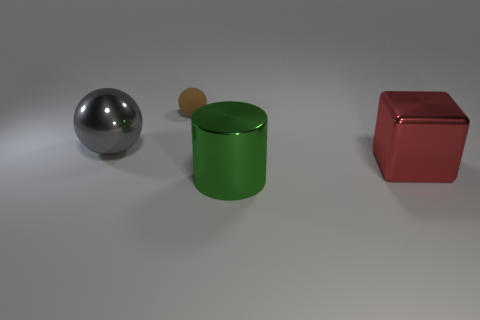Is there any other thing that has the same material as the small sphere?
Your answer should be very brief. No. How many objects are either small brown matte balls or spheres that are in front of the tiny brown rubber object?
Provide a succinct answer. 2. How many other things are the same size as the brown ball?
Make the answer very short. 0. Is the material of the gray ball that is left of the shiny cube the same as the large thing that is in front of the red cube?
Your response must be concise. Yes. How many green cylinders are on the right side of the brown ball?
Keep it short and to the point. 1. What number of purple objects are either small objects or big shiny blocks?
Your answer should be compact. 0. There is a red block that is the same size as the gray ball; what material is it?
Your response must be concise. Metal. What shape is the thing that is both behind the large red metallic thing and in front of the small brown thing?
Offer a very short reply. Sphere. There is a metal ball that is the same size as the red shiny cube; what color is it?
Provide a short and direct response. Gray. There is a thing that is in front of the large red metallic object; does it have the same size as the thing that is behind the gray ball?
Your response must be concise. No. 